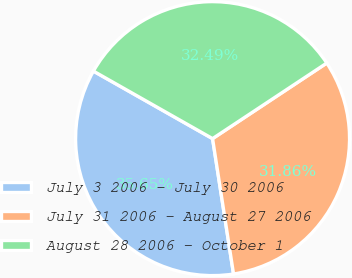<chart> <loc_0><loc_0><loc_500><loc_500><pie_chart><fcel>July 3 2006 - July 30 2006<fcel>July 31 2006 - August 27 2006<fcel>August 28 2006 - October 1<nl><fcel>35.65%<fcel>31.86%<fcel>32.49%<nl></chart> 